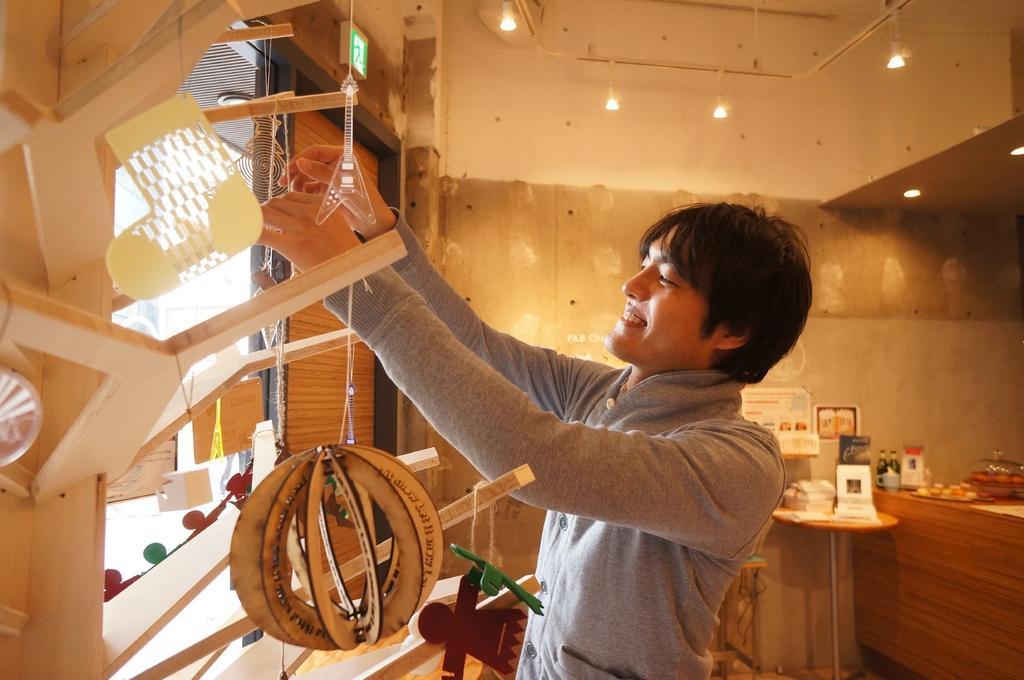How would you summarize this image in a sentence or two? This image is taken from inside. In this image we can see there is a person doing something and standing in front of the window, beside the window there is a door. On the other side of the window there is a wooden structure on which there are few objects hanging. On the right side of the image there is a kitchen platform on which there are few objects, beside that there is a table with some objects and there are few frames and posters are hanging on the wall. At the top of the image there is a ceiling with lights. 